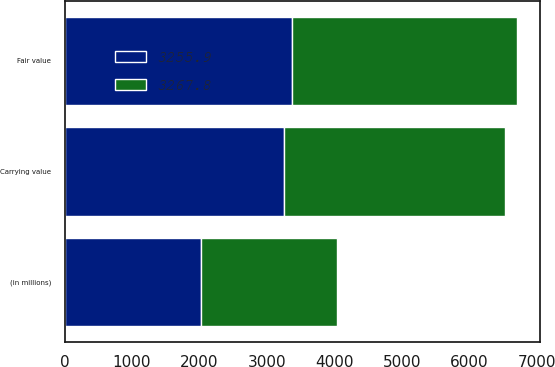<chart> <loc_0><loc_0><loc_500><loc_500><stacked_bar_chart><ecel><fcel>(in millions)<fcel>Fair value<fcel>Carrying value<nl><fcel>3255.9<fcel>2017<fcel>3366.5<fcel>3255.9<nl><fcel>3267.8<fcel>2016<fcel>3334.8<fcel>3267.8<nl></chart> 